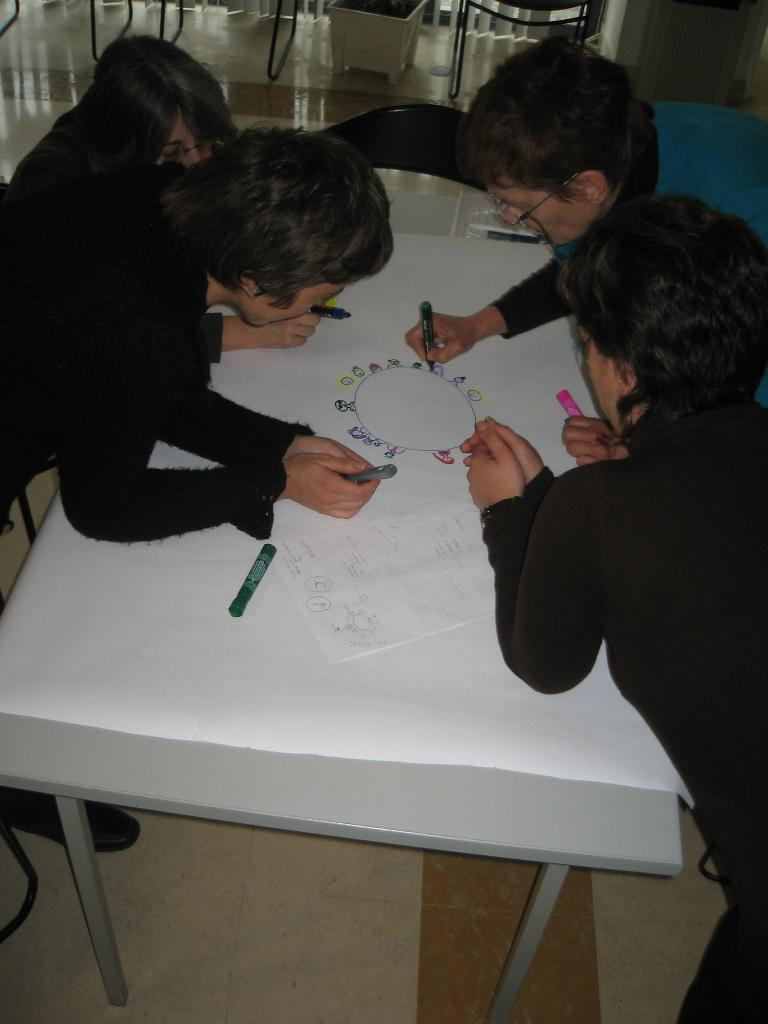How many people are present in the image? There are four people in the image. What is one of the people doing in the image? One person is drawing on a paper. Where is the paper located in the image? The paper is on a table. Where is the basin located in the image? There is no basin present in the image. What type of sponge is being used by the person drawing in the image? There is no sponge mentioned or visible in the image; the person is drawing with a pen or pencil. 